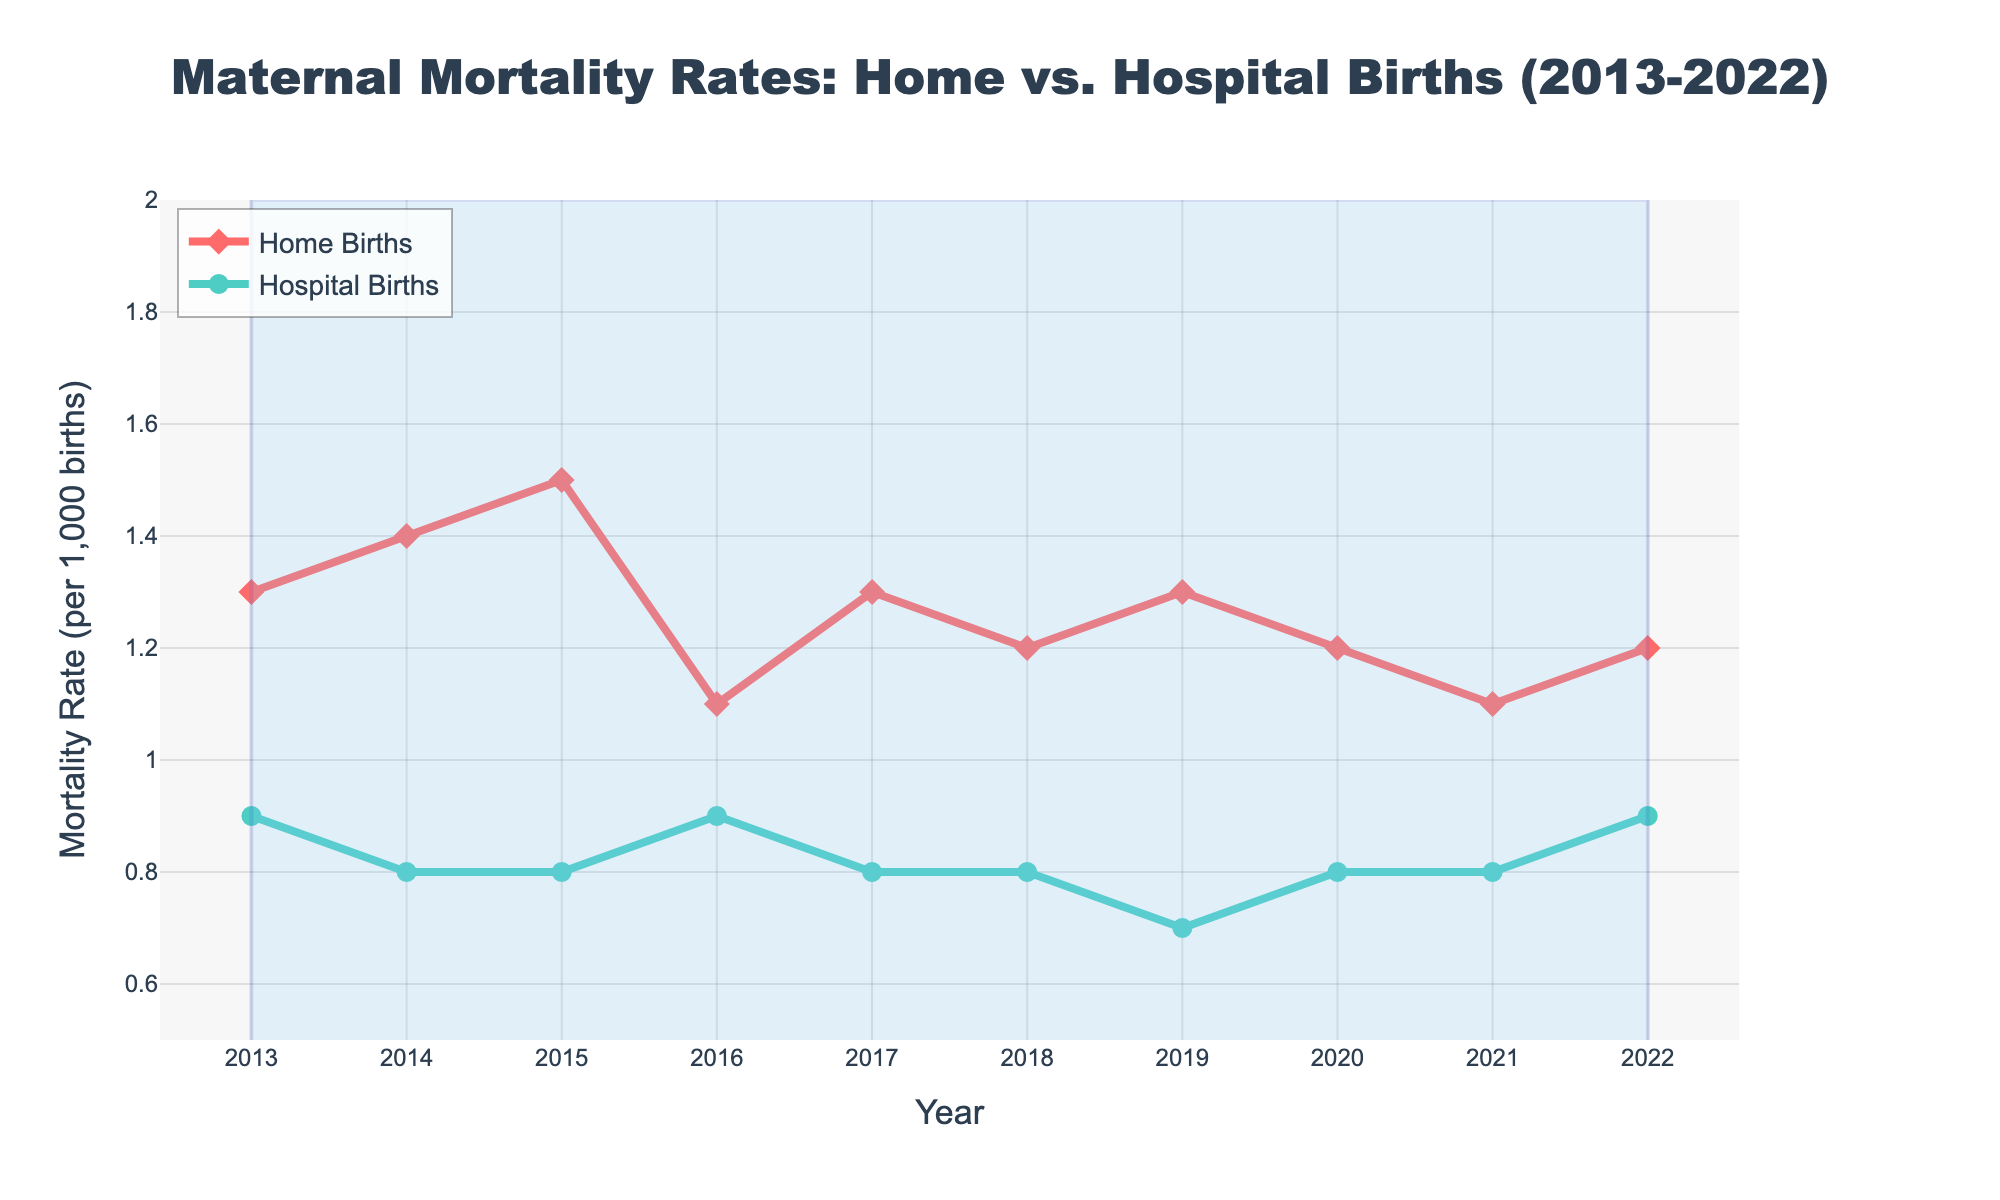What is the title of the plot? The title is displayed at the top of the plot and reads "Maternal Mortality Rates: Home vs. Hospital Births (2013-2022)."
Answer: Maternal Mortality Rates: Home vs. Hospital Births (2013-2022) Which color line represents Home Births? The Home Births line is colored in red. This can be determined by looking at the legend in the plot.
Answer: Red What is the range of the y-axis? The y-axis ranges from 0.5 to 2. This can be determined by observing the y-axis gridlines and numerical labels.
Answer: 0.5 to 2 How many data points are there for each type of birth? Each line has a data point for each year from 2013 to 2022, amounting to 10 data points per type.
Answer: 10 per type What are the mortality rates for Hospital Births in 2015 and 2019? To find these, locate the green line (Hospital Births) at the 2015 and 2019 positions on the x-axis. The rates are 0.8 for both years.
Answer: 0.8 for 2015 and 0.7 for 2019 Did the mortality rate for Home Births increase or decrease from 2015 to 2016? By comparing the positions of the red markers for 2015 and 2016, we see that the rate decreased from 1.5 to 1.1.
Answer: Decrease Which year had the highest mortality rate for Home Births, and what was the rate? Observing the red line, the highest point corresponds to the year 2015, with a mortality rate of 1.5.
Answer: 2015, 1.5 What is the average mortality rate for Hospital Births over the entire decade? Sum the mortality rates for Hospital Births from 2013 to 2022 and divide by 10: (0.9 + 0.8 + 0.8 + 0.9 + 0.8 + 0.8 + 0.7 + 0.8 + 0.8 + 0.9)/10. This results in an average rate of 0.82.
Answer: 0.82 In which years were the mortality rates for Home Births and Hospital Births equal? By examining both lines, we find that the mortality rates were never equal in any year.
Answer: Never Did the mortality rate for Hospital Births show an increasing or decreasing trend over the decade? Observing the green line, Hospital Births generally depict a stable to slightly decreasing trend from 2013 (0.9) to 2022 (0.9).
Answer: Stable to slightly decreasing 